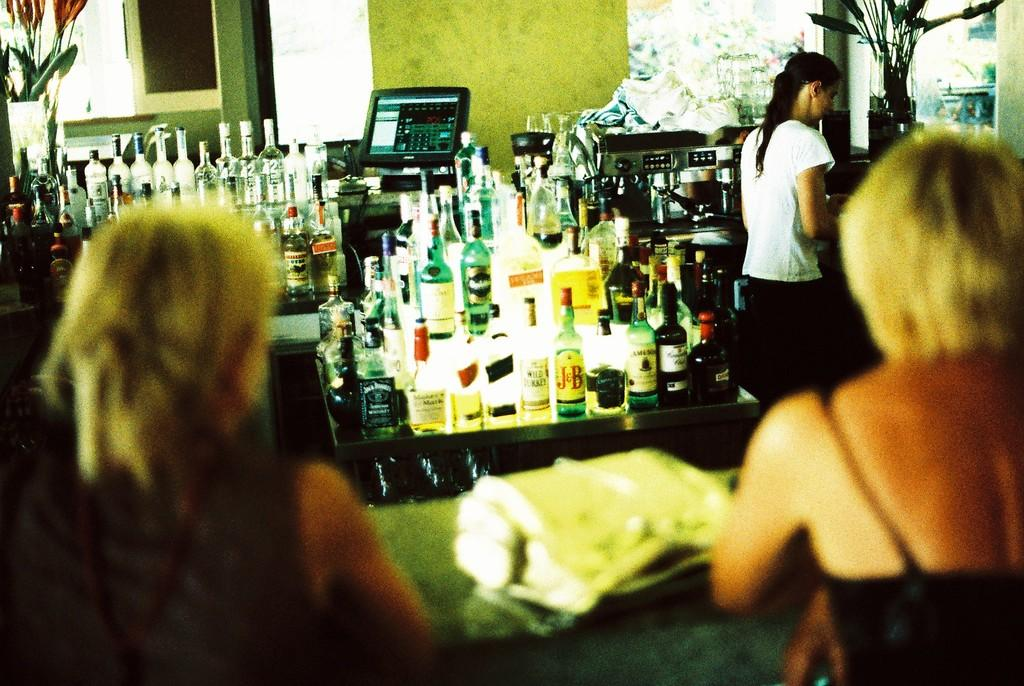What objects can be seen in the image? There are bottles and a monitor in the image. What is the woman in the image doing? The woman is standing in the image. How many women are present in the image? There are two women seated in the image, in addition to the standing woman. What type of songs can be heard coming from the bottles in the image? There are no songs coming from the bottles in the image, as bottles do not produce sound. 